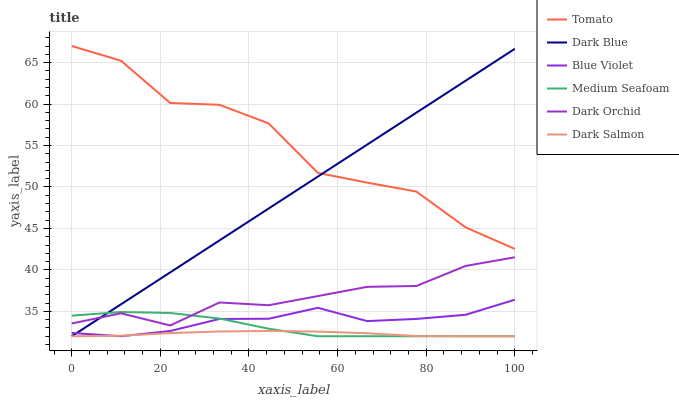Does Dark Salmon have the minimum area under the curve?
Answer yes or no. Yes. Does Tomato have the maximum area under the curve?
Answer yes or no. Yes. Does Dark Orchid have the minimum area under the curve?
Answer yes or no. No. Does Dark Orchid have the maximum area under the curve?
Answer yes or no. No. Is Dark Blue the smoothest?
Answer yes or no. Yes. Is Tomato the roughest?
Answer yes or no. Yes. Is Dark Salmon the smoothest?
Answer yes or no. No. Is Dark Salmon the roughest?
Answer yes or no. No. Does Dark Salmon have the lowest value?
Answer yes or no. Yes. Does Dark Orchid have the lowest value?
Answer yes or no. No. Does Tomato have the highest value?
Answer yes or no. Yes. Does Dark Orchid have the highest value?
Answer yes or no. No. Is Dark Salmon less than Tomato?
Answer yes or no. Yes. Is Tomato greater than Medium Seafoam?
Answer yes or no. Yes. Does Dark Salmon intersect Dark Blue?
Answer yes or no. Yes. Is Dark Salmon less than Dark Blue?
Answer yes or no. No. Is Dark Salmon greater than Dark Blue?
Answer yes or no. No. Does Dark Salmon intersect Tomato?
Answer yes or no. No. 